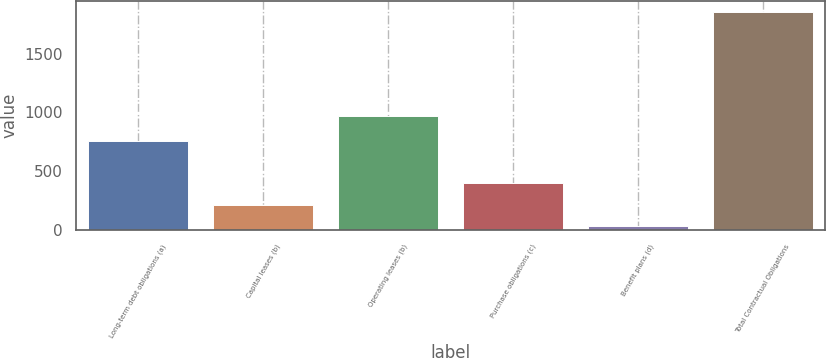Convert chart to OTSL. <chart><loc_0><loc_0><loc_500><loc_500><bar_chart><fcel>Long-term debt obligations (a)<fcel>Capital leases (b)<fcel>Operating leases (b)<fcel>Purchase obligations (c)<fcel>Benefit plans (d)<fcel>Total Contractual Obligations<nl><fcel>759<fcel>214.5<fcel>973<fcel>397<fcel>32<fcel>1857<nl></chart> 